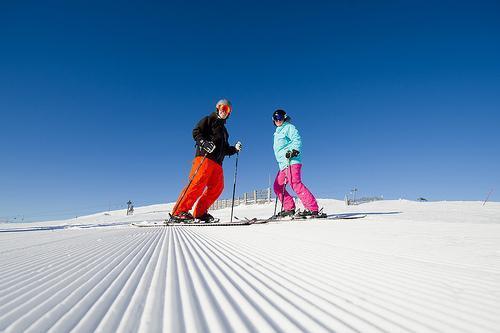How many people are there?
Give a very brief answer. 2. 